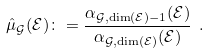Convert formula to latex. <formula><loc_0><loc_0><loc_500><loc_500>\hat { \mu } _ { \mathcal { G } } ( \mathcal { E } ) \colon = \frac { \alpha _ { \mathcal { G } , \dim ( \mathcal { E } ) - 1 } ( \mathcal { E } ) } { \alpha _ { \mathcal { G } , \dim ( \mathcal { E } ) } ( \mathcal { E } ) } \ .</formula> 